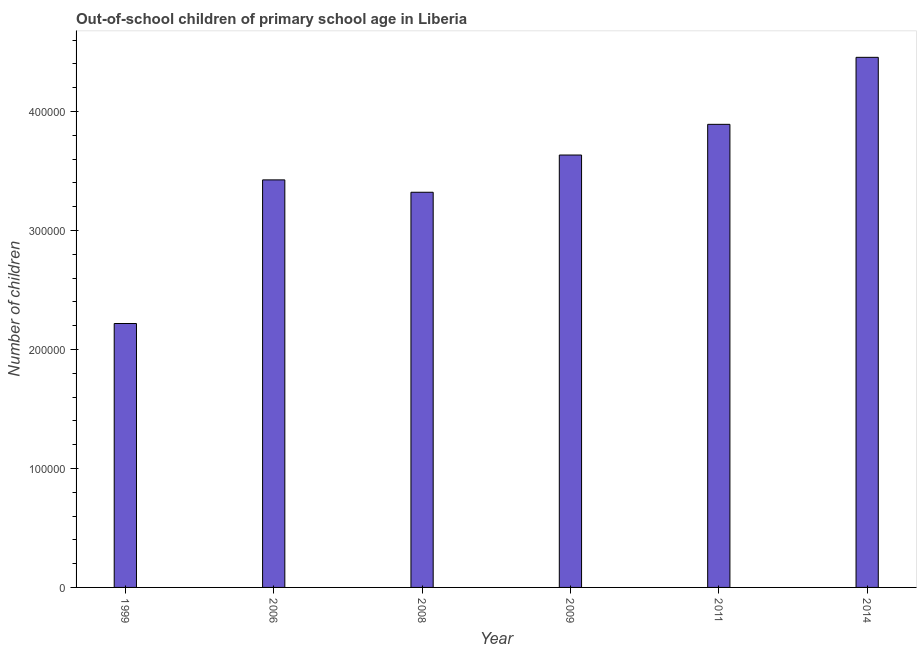Does the graph contain any zero values?
Provide a succinct answer. No. What is the title of the graph?
Your response must be concise. Out-of-school children of primary school age in Liberia. What is the label or title of the X-axis?
Your answer should be compact. Year. What is the label or title of the Y-axis?
Make the answer very short. Number of children. What is the number of out-of-school children in 1999?
Give a very brief answer. 2.22e+05. Across all years, what is the maximum number of out-of-school children?
Give a very brief answer. 4.46e+05. Across all years, what is the minimum number of out-of-school children?
Your answer should be very brief. 2.22e+05. In which year was the number of out-of-school children maximum?
Make the answer very short. 2014. In which year was the number of out-of-school children minimum?
Your answer should be compact. 1999. What is the sum of the number of out-of-school children?
Ensure brevity in your answer.  2.09e+06. What is the difference between the number of out-of-school children in 1999 and 2006?
Give a very brief answer. -1.21e+05. What is the average number of out-of-school children per year?
Make the answer very short. 3.49e+05. What is the median number of out-of-school children?
Your answer should be compact. 3.53e+05. Do a majority of the years between 2008 and 2006 (inclusive) have number of out-of-school children greater than 160000 ?
Your answer should be compact. No. What is the ratio of the number of out-of-school children in 1999 to that in 2008?
Provide a short and direct response. 0.67. Is the difference between the number of out-of-school children in 1999 and 2006 greater than the difference between any two years?
Your answer should be very brief. No. What is the difference between the highest and the second highest number of out-of-school children?
Your answer should be compact. 5.63e+04. What is the difference between the highest and the lowest number of out-of-school children?
Keep it short and to the point. 2.24e+05. What is the difference between two consecutive major ticks on the Y-axis?
Offer a very short reply. 1.00e+05. What is the Number of children in 1999?
Ensure brevity in your answer.  2.22e+05. What is the Number of children in 2006?
Provide a succinct answer. 3.43e+05. What is the Number of children of 2008?
Give a very brief answer. 3.32e+05. What is the Number of children of 2009?
Give a very brief answer. 3.63e+05. What is the Number of children of 2011?
Offer a terse response. 3.89e+05. What is the Number of children in 2014?
Your answer should be compact. 4.46e+05. What is the difference between the Number of children in 1999 and 2006?
Offer a terse response. -1.21e+05. What is the difference between the Number of children in 1999 and 2008?
Ensure brevity in your answer.  -1.10e+05. What is the difference between the Number of children in 1999 and 2009?
Keep it short and to the point. -1.42e+05. What is the difference between the Number of children in 1999 and 2011?
Your answer should be compact. -1.67e+05. What is the difference between the Number of children in 1999 and 2014?
Provide a succinct answer. -2.24e+05. What is the difference between the Number of children in 2006 and 2008?
Your answer should be very brief. 1.04e+04. What is the difference between the Number of children in 2006 and 2009?
Keep it short and to the point. -2.09e+04. What is the difference between the Number of children in 2006 and 2011?
Make the answer very short. -4.67e+04. What is the difference between the Number of children in 2006 and 2014?
Your answer should be very brief. -1.03e+05. What is the difference between the Number of children in 2008 and 2009?
Make the answer very short. -3.13e+04. What is the difference between the Number of children in 2008 and 2011?
Your response must be concise. -5.71e+04. What is the difference between the Number of children in 2008 and 2014?
Offer a terse response. -1.13e+05. What is the difference between the Number of children in 2009 and 2011?
Your answer should be compact. -2.58e+04. What is the difference between the Number of children in 2009 and 2014?
Offer a very short reply. -8.21e+04. What is the difference between the Number of children in 2011 and 2014?
Provide a succinct answer. -5.63e+04. What is the ratio of the Number of children in 1999 to that in 2006?
Provide a short and direct response. 0.65. What is the ratio of the Number of children in 1999 to that in 2008?
Make the answer very short. 0.67. What is the ratio of the Number of children in 1999 to that in 2009?
Keep it short and to the point. 0.61. What is the ratio of the Number of children in 1999 to that in 2011?
Provide a succinct answer. 0.57. What is the ratio of the Number of children in 1999 to that in 2014?
Keep it short and to the point. 0.5. What is the ratio of the Number of children in 2006 to that in 2008?
Give a very brief answer. 1.03. What is the ratio of the Number of children in 2006 to that in 2009?
Provide a short and direct response. 0.94. What is the ratio of the Number of children in 2006 to that in 2011?
Your answer should be compact. 0.88. What is the ratio of the Number of children in 2006 to that in 2014?
Offer a very short reply. 0.77. What is the ratio of the Number of children in 2008 to that in 2009?
Offer a very short reply. 0.91. What is the ratio of the Number of children in 2008 to that in 2011?
Provide a succinct answer. 0.85. What is the ratio of the Number of children in 2008 to that in 2014?
Provide a short and direct response. 0.74. What is the ratio of the Number of children in 2009 to that in 2011?
Provide a succinct answer. 0.93. What is the ratio of the Number of children in 2009 to that in 2014?
Offer a very short reply. 0.82. What is the ratio of the Number of children in 2011 to that in 2014?
Your answer should be compact. 0.87. 